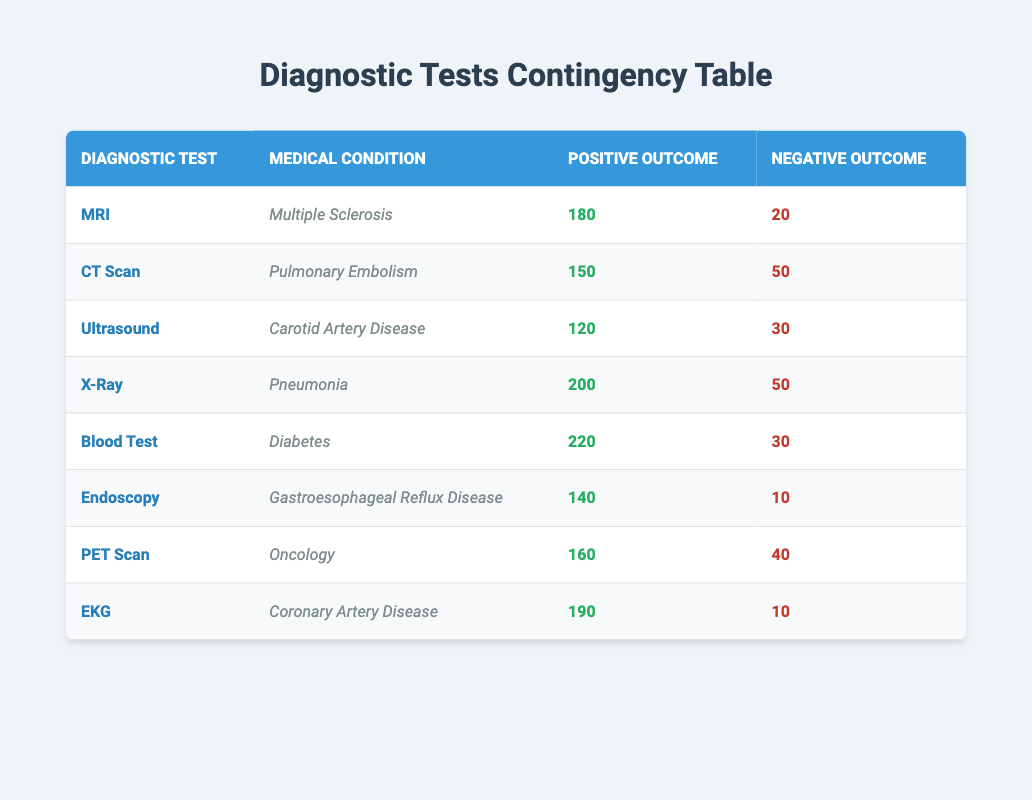What is the positive outcome of the Blood Test for Diabetes? The table lists the outcomes for each test. Under the "Blood Test" row for "Diabetes," the "Positive Outcome" value is 220.
Answer: 220 What is the negative outcome for the X-Ray in Pneumonia? Looking at the X-Ray row in the table, the "Negative Outcome" for "Pneumonia" is 50.
Answer: 50 Which diagnostic test has the highest number of positive outcomes? By examining the positive outcomes for all tests, the Blood Test for Diabetes has the highest value at 220 compared to other tests which have lower values.
Answer: Blood Test Are there more positive outcomes for EKG in Coronary Artery Disease than for Endoscopy in Gastroesophageal Reflux Disease? The positive outcome for EKG is 190, while for Endoscopy it is 140. Since 190 is greater than 140, the answer is yes.
Answer: Yes What is the total number of negative outcomes across all tests? To find the total, we sum all the negative outcomes: 20 (MRI) + 50 (CT Scan) + 30 (Ultrasound) + 50 (X-Ray) + 30 (Blood Test) + 10 (Endoscopy) + 40 (PET Scan) + 10 (EKG) = 300.
Answer: 300 What is the average positive outcome across all diagnostic tests? First, we sum the positive outcomes: 180 + 150 + 120 + 200 + 220 + 140 + 160 + 190 = 1260. There are 8 tests, so the average is 1260 / 8 = 157.5.
Answer: 157.5 Is there a diagnostic test with fewer than 100 positive outcomes? Reviewing the table, we can see all tests have positive outcomes above 100; thus, no test has fewer than 100 positive outcomes.
Answer: No What is the difference in the number of positive outcomes between MRI and CT Scan? The positive outcomes are 180 for MRI and 150 for CT Scan. The difference is 180 - 150 = 30.
Answer: 30 Which medical condition had the lowest positive outcome? Evaluating the positive outcomes, Ultrasound for Carotid Artery Disease had the lowest at 120, compared to other conditions.
Answer: Carotid Artery Disease 